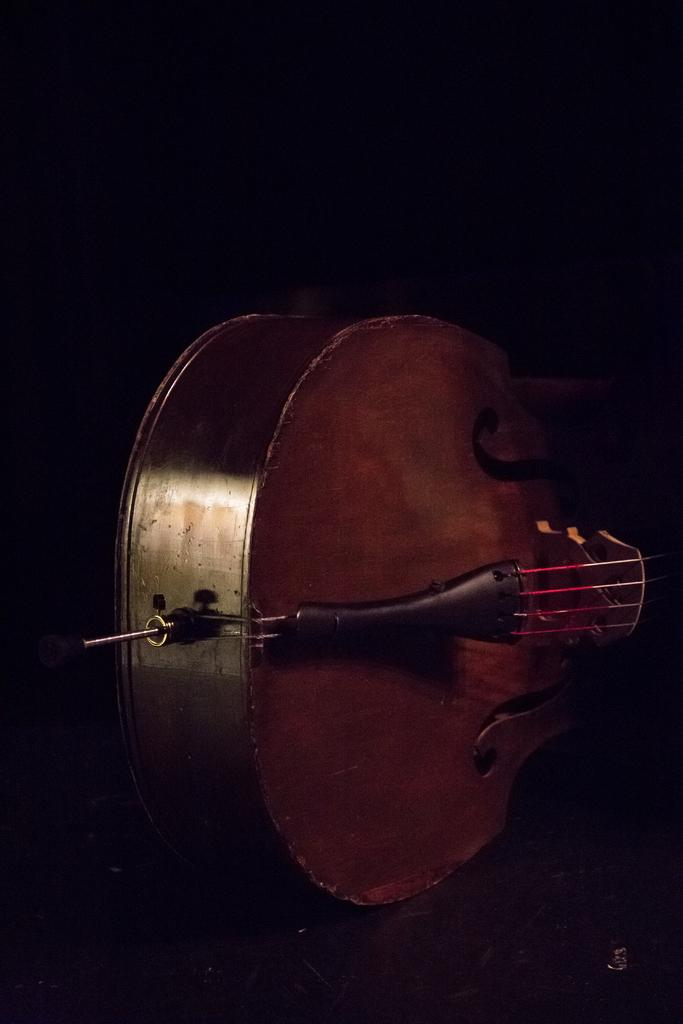What musical instrument is featured in the image? There is a guitar in the image. What are the guitar's strings used for? The guitar's strings are used for playing music. What is the color of the guitar in the image? The guitar is brown in color. What can be observed about the background of the image? The background of the image is dark. How does the guitar use its brake to slow down while playing? Guitars do not have brakes; they are musical instruments that use strings and a fretboard to produce sound. What type of trade is being conducted in the image? There is no indication of any trade being conducted in the image; it features a guitar. 